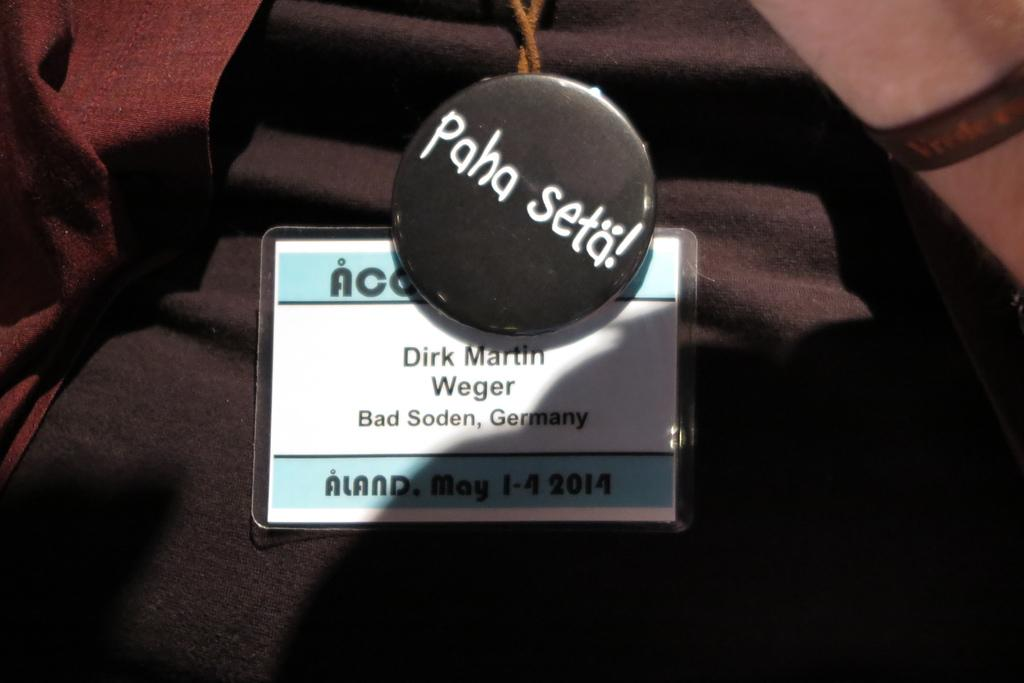What is the main object in the image? There is a cloth in the image. Is there anything attached to the cloth? Yes, the cloth has a tag on it. What else can be seen on the cloth? There is a card on the cloth. Can you see any part of a person in the image? Yes, a person's hand is visible in the top right corner of the image. What type of poison is being applied to the tomatoes on the cloth? There are no tomatoes present in the image, and no poison is being applied to any objects. Is there a guitar visible in the image? No, there is no guitar present in the image. 